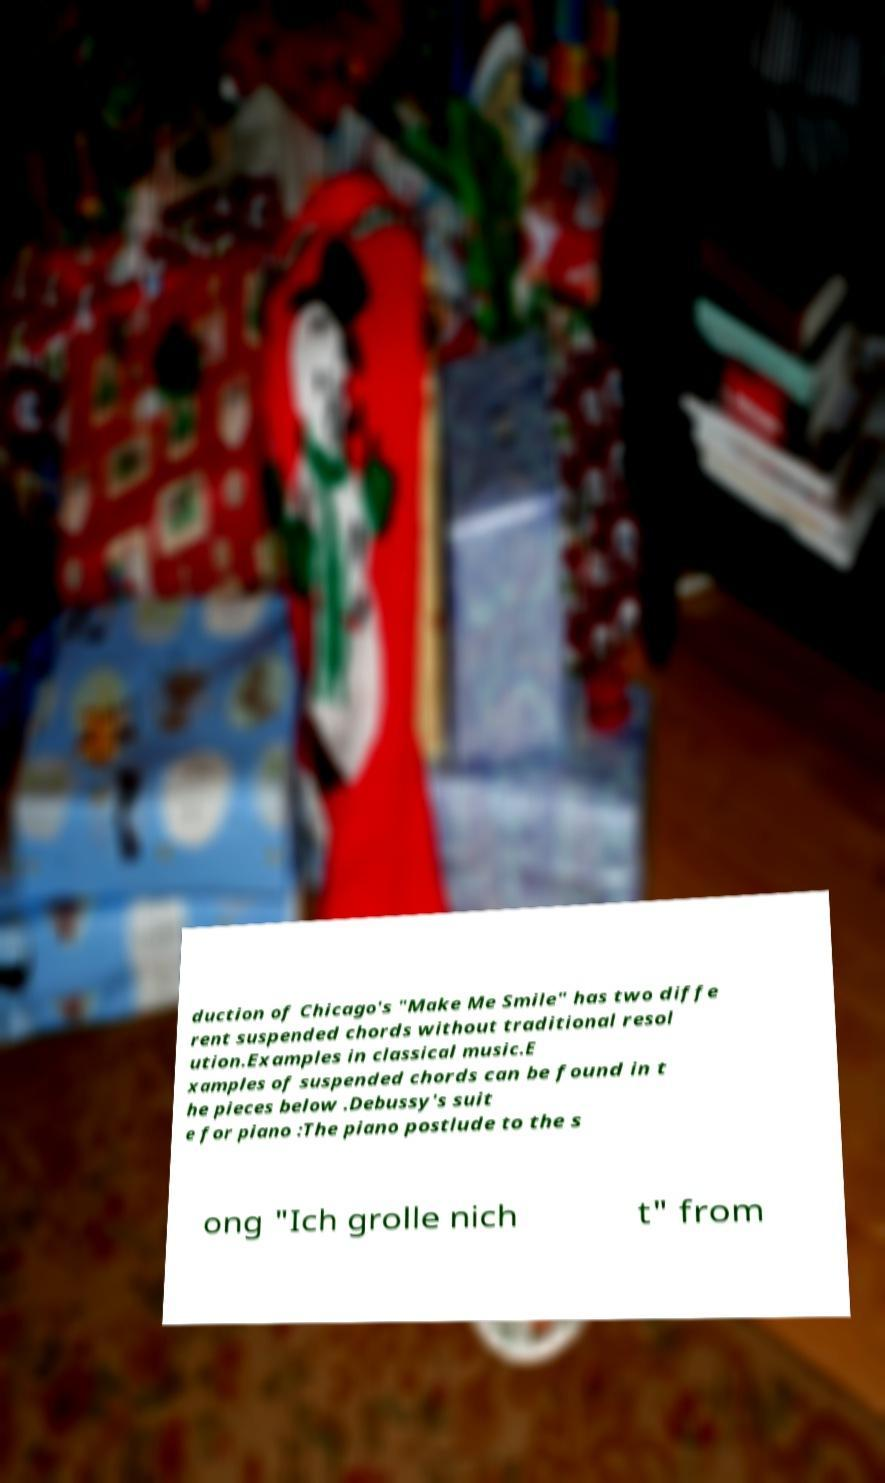Can you read and provide the text displayed in the image?This photo seems to have some interesting text. Can you extract and type it out for me? duction of Chicago's "Make Me Smile" has two diffe rent suspended chords without traditional resol ution.Examples in classical music.E xamples of suspended chords can be found in t he pieces below .Debussy's suit e for piano :The piano postlude to the s ong "Ich grolle nich t" from 